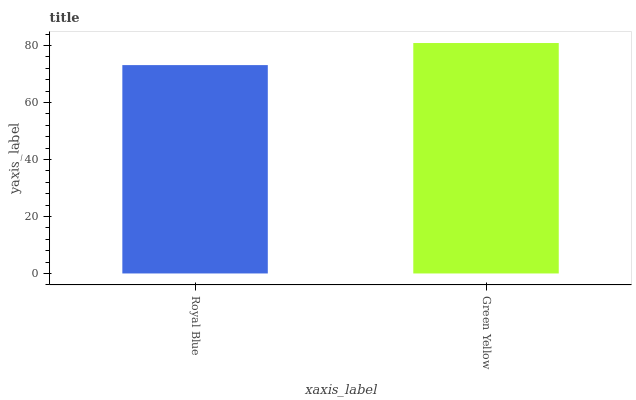Is Royal Blue the minimum?
Answer yes or no. Yes. Is Green Yellow the maximum?
Answer yes or no. Yes. Is Green Yellow the minimum?
Answer yes or no. No. Is Green Yellow greater than Royal Blue?
Answer yes or no. Yes. Is Royal Blue less than Green Yellow?
Answer yes or no. Yes. Is Royal Blue greater than Green Yellow?
Answer yes or no. No. Is Green Yellow less than Royal Blue?
Answer yes or no. No. Is Green Yellow the high median?
Answer yes or no. Yes. Is Royal Blue the low median?
Answer yes or no. Yes. Is Royal Blue the high median?
Answer yes or no. No. Is Green Yellow the low median?
Answer yes or no. No. 